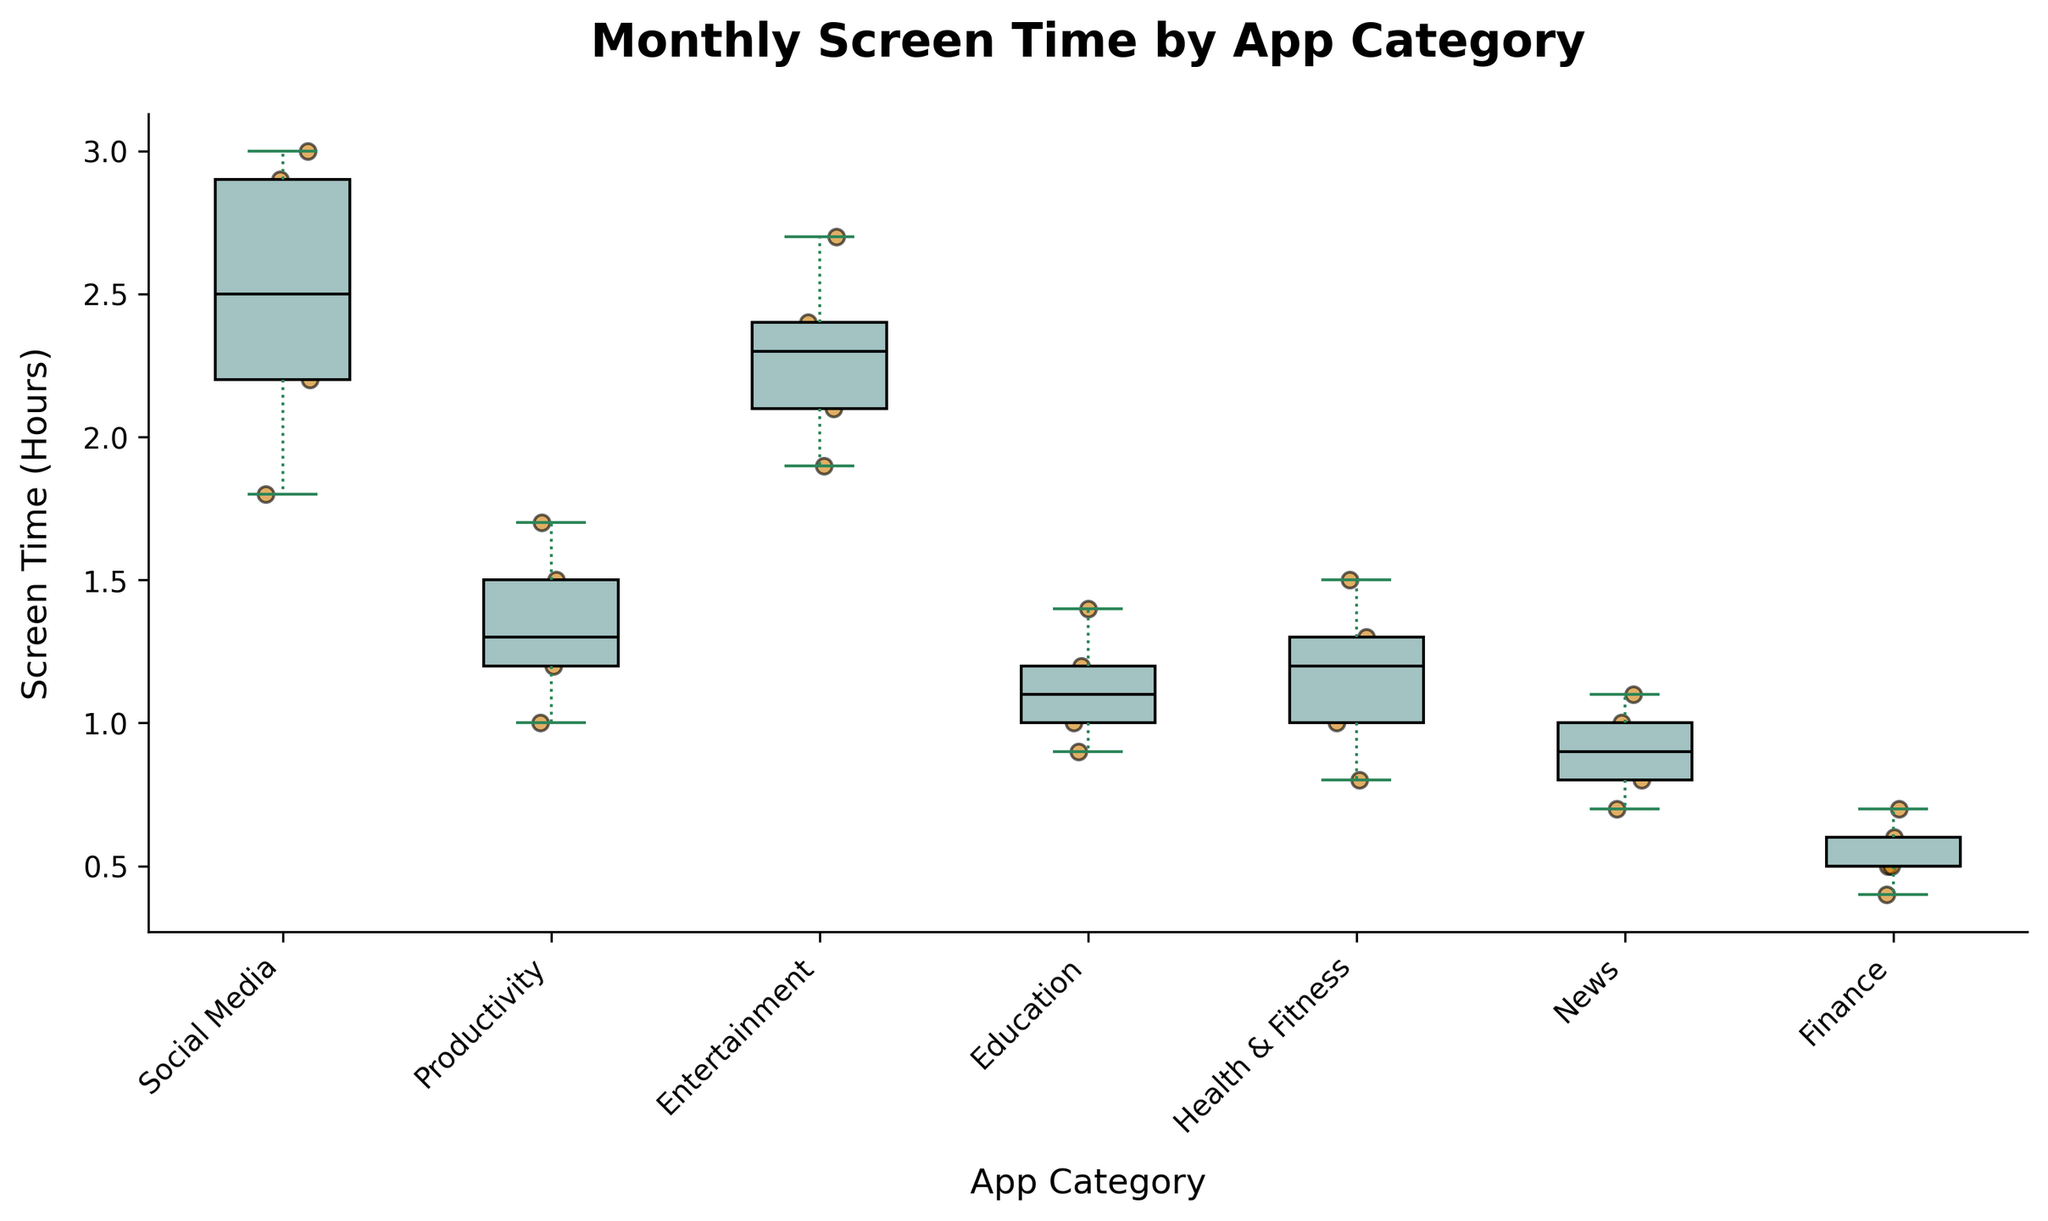what is the title of the plot? The title of the plot is normally found at the top center of the figure. By looking at the visual, you can read the text displayed in that position.
Answer: 'Monthly Screen Time by App Category' which app category has the highest average screen time? To determine the app category with the highest average screen time, look at the position of the median line inside the box for each category. The category with the highest median line has the highest average screen time.
Answer: Social Media what color are the scatter points? To find the color of the scatter points, look at the individual dots scattered around the boxplots. The color of these dots is a specific visual element designed to stand out.
Answer: Orange how many app categories are represented in the plot? The number of app categories can be determined by counting the distinct groups labeled on the x-axis. These labels represent each category present in the dataset.
Answer: Six which app category has the smallest range in screen time? The range is determined by the distance between the top whisker and the bottom whisker of the boxplot. The category with the smallest vertical distance between these whiskers has the smallest range.
Answer: Finance which app category has the widest distribution of screen time? To identify the widest distribution, look at which boxplot has the largest distance between the top and bottom whiskers. This distance represents the full spread of the data for each category.
Answer: Entertainment are there any outliers in the dataset? Outliers in a boxplot are often represented by individual points that fall outside the whiskers of the boxplot. Visually inspect each category's plot to see if any dots fall noticeably outside the whiskers.
Answer: No what is the median screen time for the Education category? The median is indicated by a line within the box of the boxplot. Find the box for the Education category and note the value of this line.
Answer: 1.1 hours compare the screen time usage between News and Health & Fitness categories. which one has higher variability? Variability can be assessed by looking at the length of the boxes and whiskers. The category with a longer distance between its whiskers and a taller box has higher variability.
Answer: Health & Fitness which app category shows the most consistent screen time usage? Consistency can be inferred from boxplots with smaller boxes and shorter whiskers. The category with the smallest combined height of the box and whiskers shows the most consistent usage.
Answer: Finance 